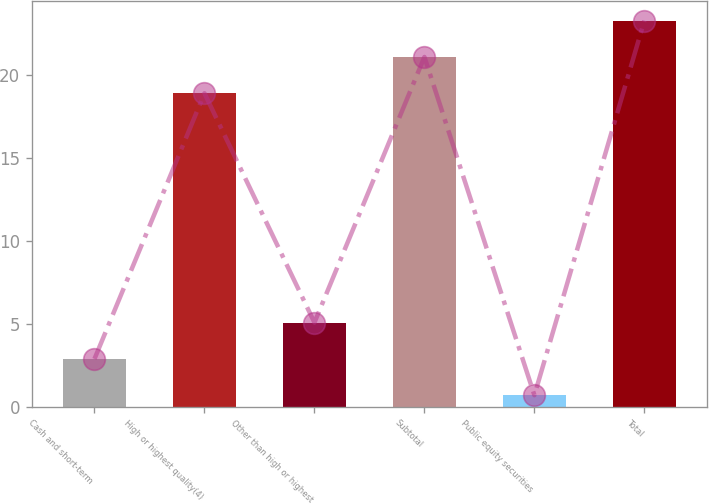Convert chart to OTSL. <chart><loc_0><loc_0><loc_500><loc_500><bar_chart><fcel>Cash and short-term<fcel>High or highest quality(4)<fcel>Other than high or highest<fcel>Subtotal<fcel>Public equity securities<fcel>Total<nl><fcel>2.89<fcel>18.9<fcel>5.08<fcel>21.09<fcel>0.7<fcel>23.28<nl></chart> 